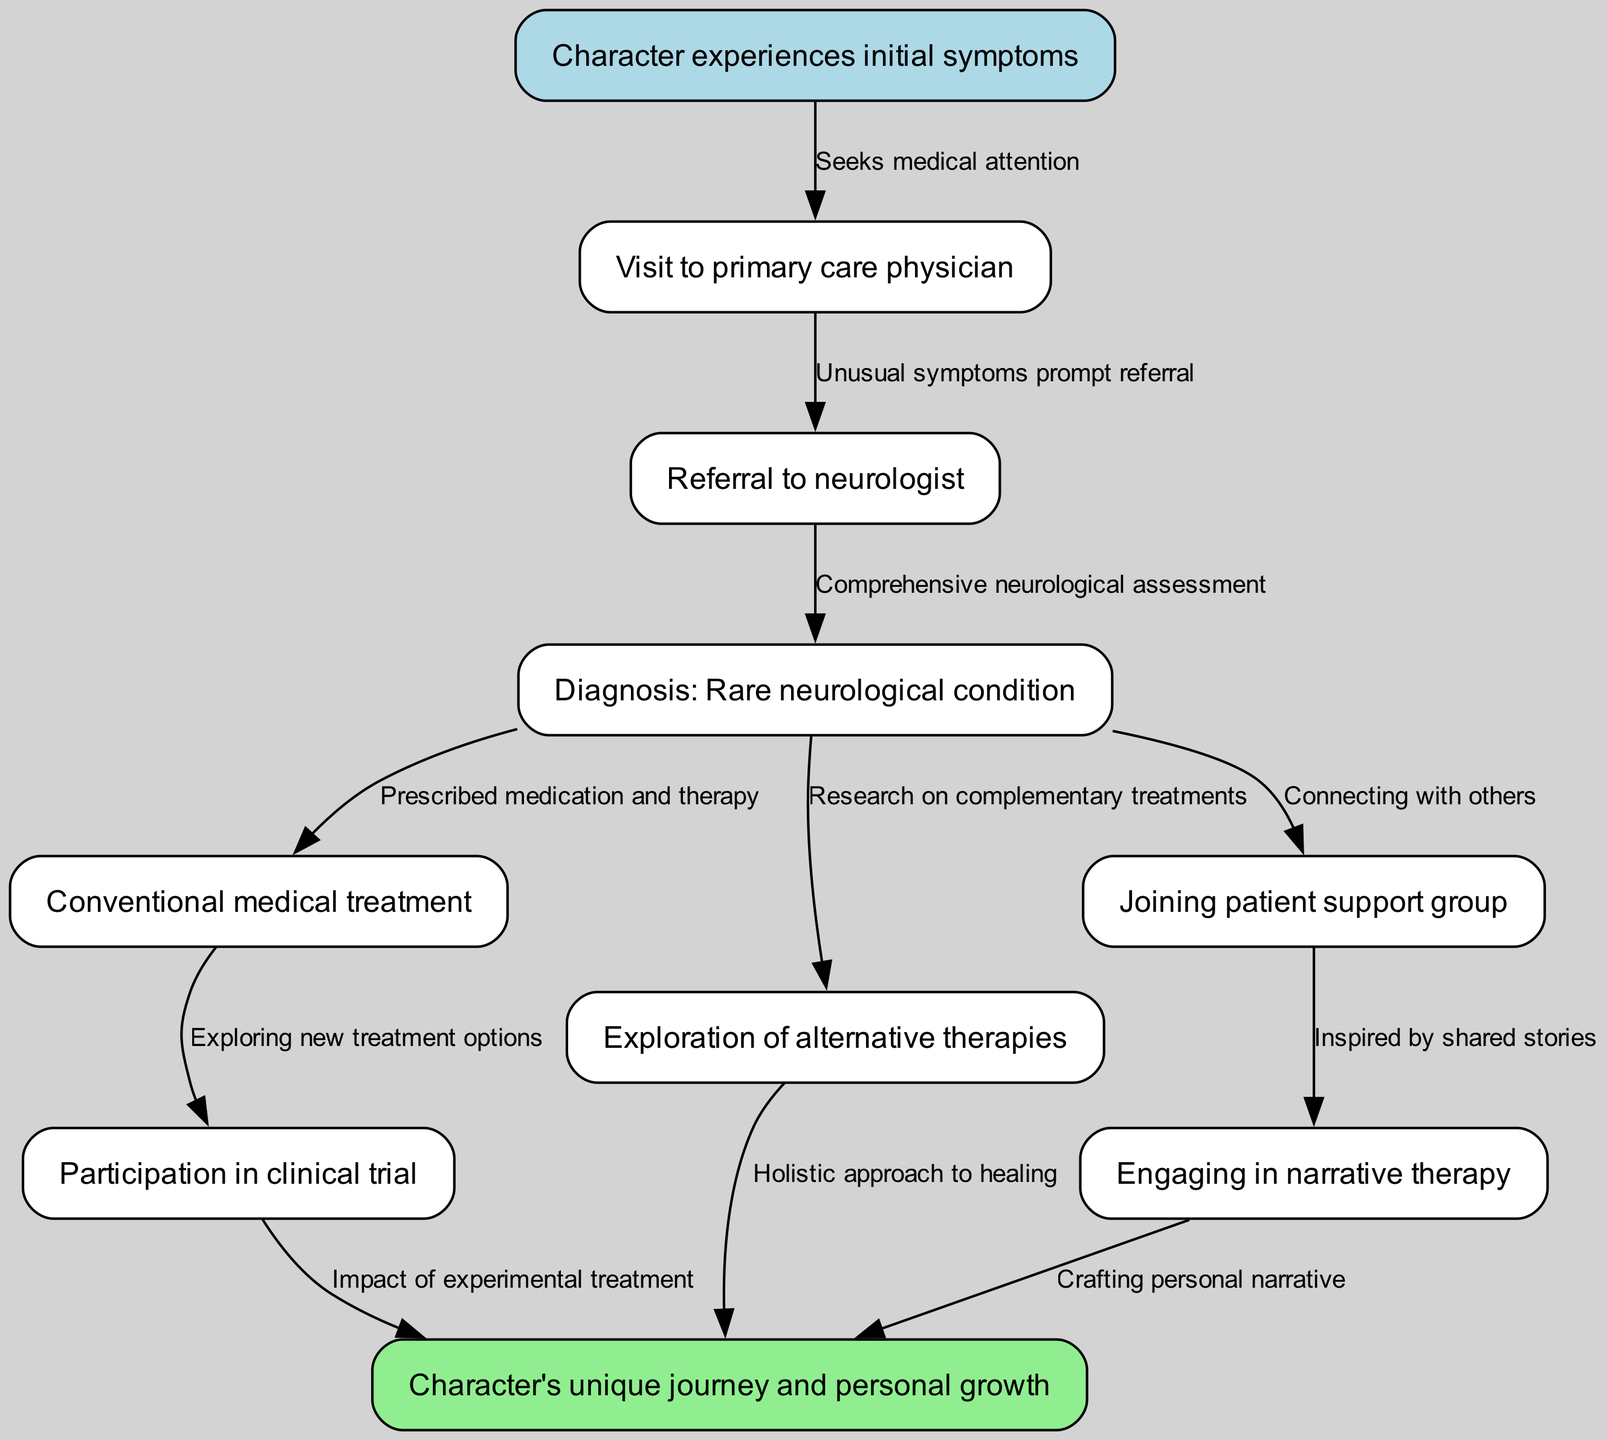What are the initial symptoms experienced by the character? The diagram starts with the node labeled "Character experiences initial symptoms," which is the first point in the treatment journey and indicates the beginning of the character's medical issues.
Answer: Character experiences initial symptoms How many alternative therapies are explored? The diagram indicates one node labeled "Exploration of alternative therapies," suggesting that one main alternative approach is considered during the journey.
Answer: One What is prescribed after the diagnosis of the rare neurological condition? Following the "Diagnosis: Rare neurological condition" node, there is a directed edge to "Conventional medical treatment," which shows that medication and therapy are prescribed after diagnosis.
Answer: Conventional medical treatment What prompts the visit to the primary care physician? The edge connecting "Character experiences initial symptoms" to "Visit to primary care physician" is labeled "Seeks medical attention," indicating that the witnessed symptoms lead to the visit.
Answer: Seeks medical attention Which therapy is inspired by shared stories from a support group? The diagram shows an edge from the "Joining patient support group" node to "Engaging in narrative therapy," where the label indicates the influence of shared experiences on narrative therapy.
Answer: Engaging in narrative therapy What is the ultimate outcome of the character's journey? The diagram shows the final node connected to multiple paths, labeled "Character's unique journey and personal growth," indicating the culmination of the character's experiences.
Answer: Character's unique journey and personal growth How does the character engage with experimental treatment? The character's path from "Conventional medical treatment" to "Participation in clinical trial" indicates that the character explores new treatment options as part of their journey.
Answer: Participation in clinical trial Which node indicates connecting with others? The diagram outlines a direct link from the diagnosis node to the "Joining patient support group" node, confirming the action of connecting with other individuals dealing with similar conditions.
Answer: Joining patient support group What influences the crafting of a personal narrative? The connection from "Engaging in narrative therapy" to "Character's unique journey and personal growth" illustrates that narrative therapy impacts the character's ability to craft their own personal narrative.
Answer: Crafting personal narrative 